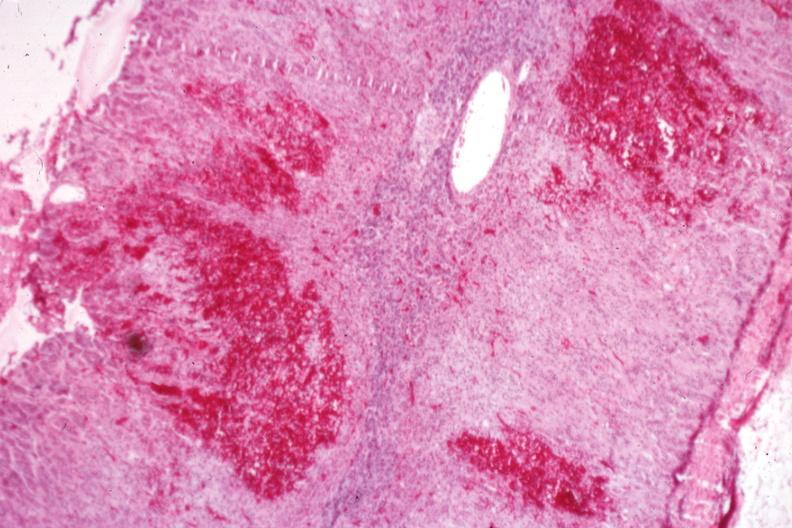where is this part in the figure?
Answer the question using a single word or phrase. Endocrine system 